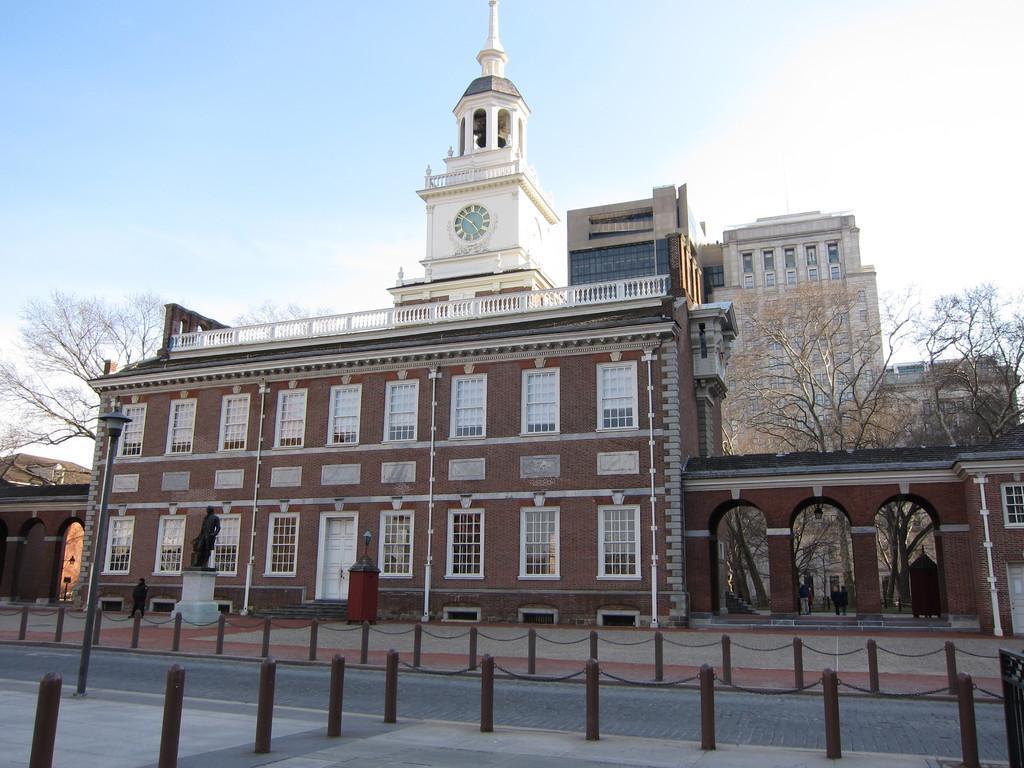Please provide a concise description of this image. In this image I see the buildings and I see the path and I see the statue over here and I see the street light over here. In the background I see the trees and the sky and I see few people. 